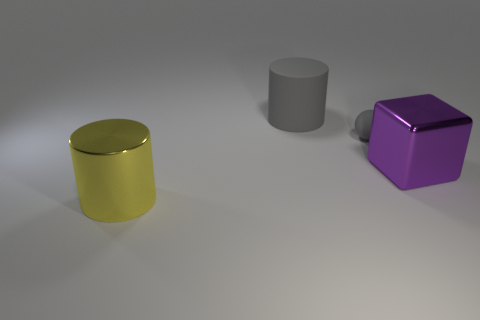Is the number of gray matte cylinders right of the big purple object less than the number of big purple metallic cubes?
Your answer should be very brief. Yes. Does the large matte object have the same shape as the large yellow object?
Your response must be concise. Yes. Are there any other things that have the same shape as the tiny gray matte object?
Provide a short and direct response. No. Are there any tiny gray matte cylinders?
Your answer should be compact. No. Does the yellow metal object have the same shape as the big metallic thing to the right of the sphere?
Provide a succinct answer. No. There is a gray thing in front of the large thing behind the gray matte sphere; what is its material?
Provide a succinct answer. Rubber. What is the color of the large shiny cylinder?
Keep it short and to the point. Yellow. Does the big metal thing that is on the left side of the gray cylinder have the same color as the metal object that is on the right side of the rubber cylinder?
Ensure brevity in your answer.  No. What is the size of the other thing that is the same shape as the big matte object?
Make the answer very short. Large. Is there a matte sphere that has the same color as the cube?
Your answer should be very brief. No. 